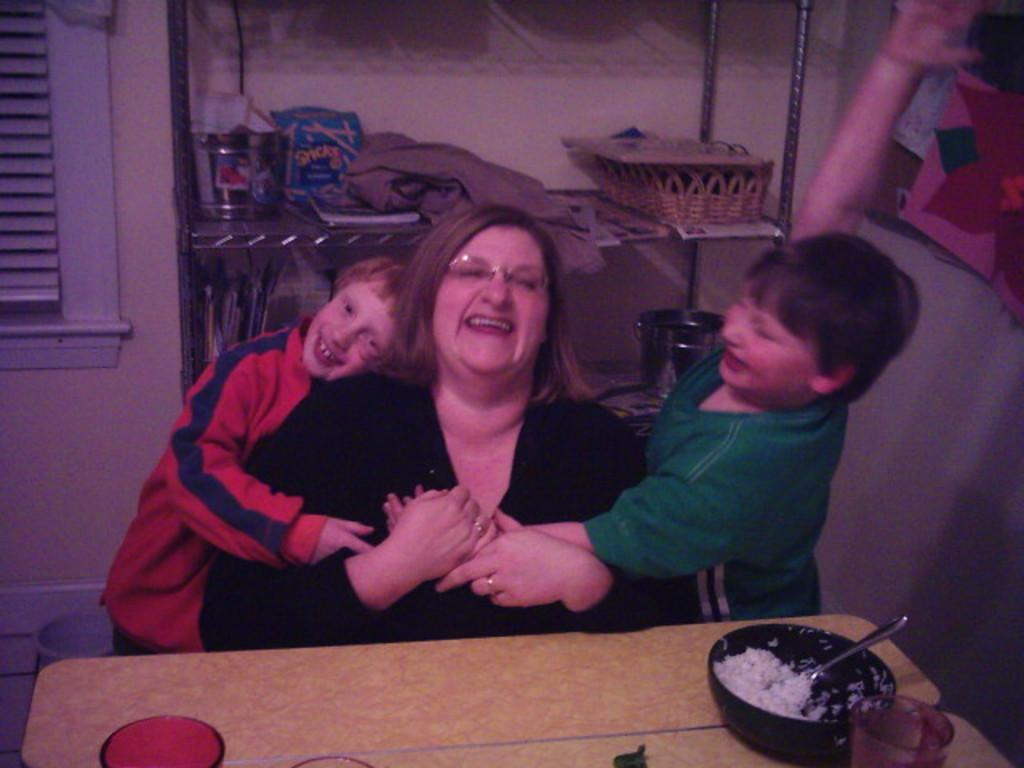How many people are in the image? There are three persons in the image. What is the age group of two of the people? Two of them are kids. What are the kids doing in the image? The kids are playing with a woman. What can be seen on the right side of the image? There is a rice bowl on the right side of the image. What is visible in the background of the image? There are objects in the background of the image. Where is the nest of tomatoes located in the image? There is no nest or tomatoes present in the image. What type of metal object can be seen in the image? There is no metal object present in the image. 